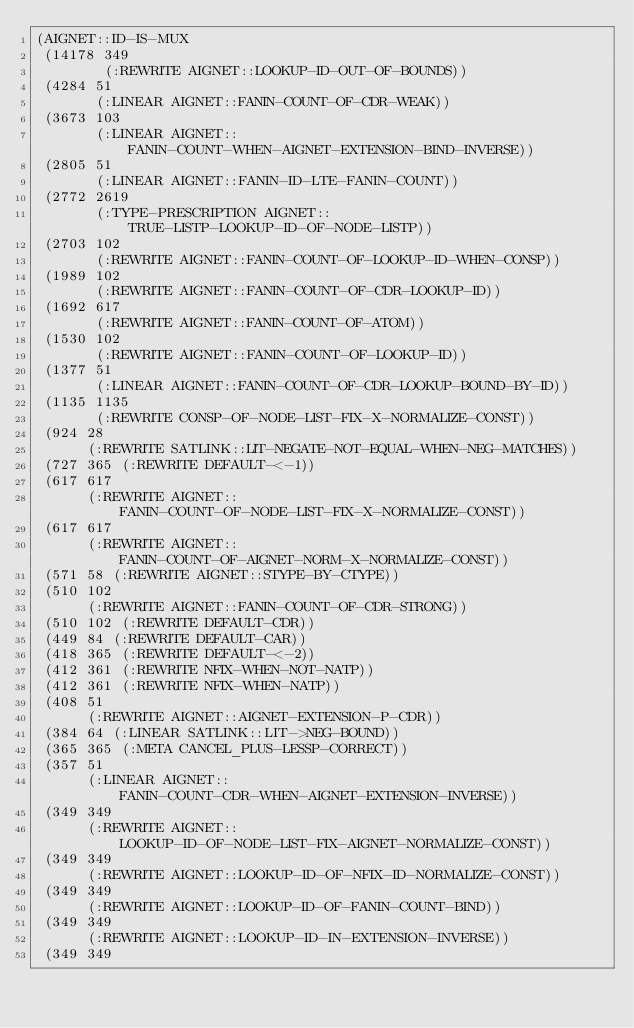Convert code to text. <code><loc_0><loc_0><loc_500><loc_500><_Lisp_>(AIGNET::ID-IS-MUX
 (14178 349
        (:REWRITE AIGNET::LOOKUP-ID-OUT-OF-BOUNDS))
 (4284 51
       (:LINEAR AIGNET::FANIN-COUNT-OF-CDR-WEAK))
 (3673 103
       (:LINEAR AIGNET::FANIN-COUNT-WHEN-AIGNET-EXTENSION-BIND-INVERSE))
 (2805 51
       (:LINEAR AIGNET::FANIN-ID-LTE-FANIN-COUNT))
 (2772 2619
       (:TYPE-PRESCRIPTION AIGNET::TRUE-LISTP-LOOKUP-ID-OF-NODE-LISTP))
 (2703 102
       (:REWRITE AIGNET::FANIN-COUNT-OF-LOOKUP-ID-WHEN-CONSP))
 (1989 102
       (:REWRITE AIGNET::FANIN-COUNT-OF-CDR-LOOKUP-ID))
 (1692 617
       (:REWRITE AIGNET::FANIN-COUNT-OF-ATOM))
 (1530 102
       (:REWRITE AIGNET::FANIN-COUNT-OF-LOOKUP-ID))
 (1377 51
       (:LINEAR AIGNET::FANIN-COUNT-OF-CDR-LOOKUP-BOUND-BY-ID))
 (1135 1135
       (:REWRITE CONSP-OF-NODE-LIST-FIX-X-NORMALIZE-CONST))
 (924 28
      (:REWRITE SATLINK::LIT-NEGATE-NOT-EQUAL-WHEN-NEG-MATCHES))
 (727 365 (:REWRITE DEFAULT-<-1))
 (617 617
      (:REWRITE AIGNET::FANIN-COUNT-OF-NODE-LIST-FIX-X-NORMALIZE-CONST))
 (617 617
      (:REWRITE AIGNET::FANIN-COUNT-OF-AIGNET-NORM-X-NORMALIZE-CONST))
 (571 58 (:REWRITE AIGNET::STYPE-BY-CTYPE))
 (510 102
      (:REWRITE AIGNET::FANIN-COUNT-OF-CDR-STRONG))
 (510 102 (:REWRITE DEFAULT-CDR))
 (449 84 (:REWRITE DEFAULT-CAR))
 (418 365 (:REWRITE DEFAULT-<-2))
 (412 361 (:REWRITE NFIX-WHEN-NOT-NATP))
 (412 361 (:REWRITE NFIX-WHEN-NATP))
 (408 51
      (:REWRITE AIGNET::AIGNET-EXTENSION-P-CDR))
 (384 64 (:LINEAR SATLINK::LIT->NEG-BOUND))
 (365 365 (:META CANCEL_PLUS-LESSP-CORRECT))
 (357 51
      (:LINEAR AIGNET::FANIN-COUNT-CDR-WHEN-AIGNET-EXTENSION-INVERSE))
 (349 349
      (:REWRITE AIGNET::LOOKUP-ID-OF-NODE-LIST-FIX-AIGNET-NORMALIZE-CONST))
 (349 349
      (:REWRITE AIGNET::LOOKUP-ID-OF-NFIX-ID-NORMALIZE-CONST))
 (349 349
      (:REWRITE AIGNET::LOOKUP-ID-OF-FANIN-COUNT-BIND))
 (349 349
      (:REWRITE AIGNET::LOOKUP-ID-IN-EXTENSION-INVERSE))
 (349 349</code> 